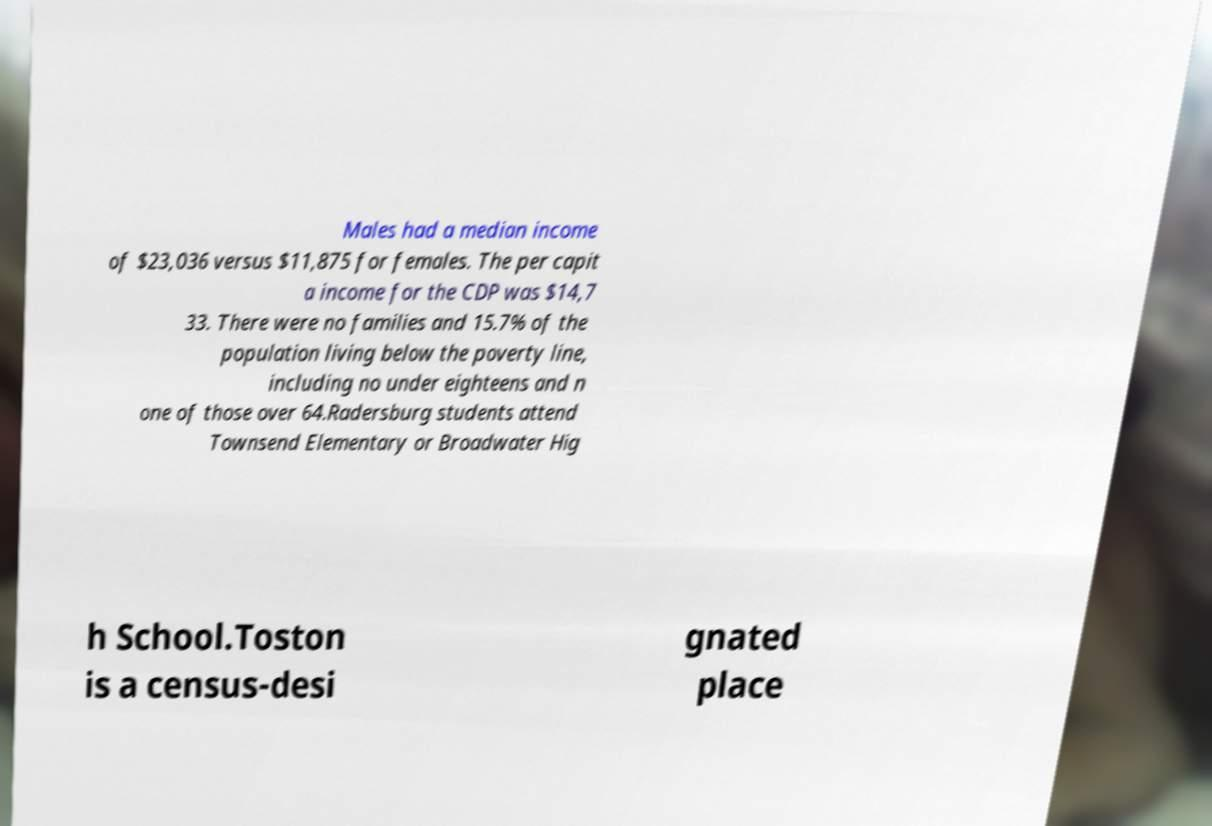What messages or text are displayed in this image? I need them in a readable, typed format. Males had a median income of $23,036 versus $11,875 for females. The per capit a income for the CDP was $14,7 33. There were no families and 15.7% of the population living below the poverty line, including no under eighteens and n one of those over 64.Radersburg students attend Townsend Elementary or Broadwater Hig h School.Toston is a census-desi gnated place 